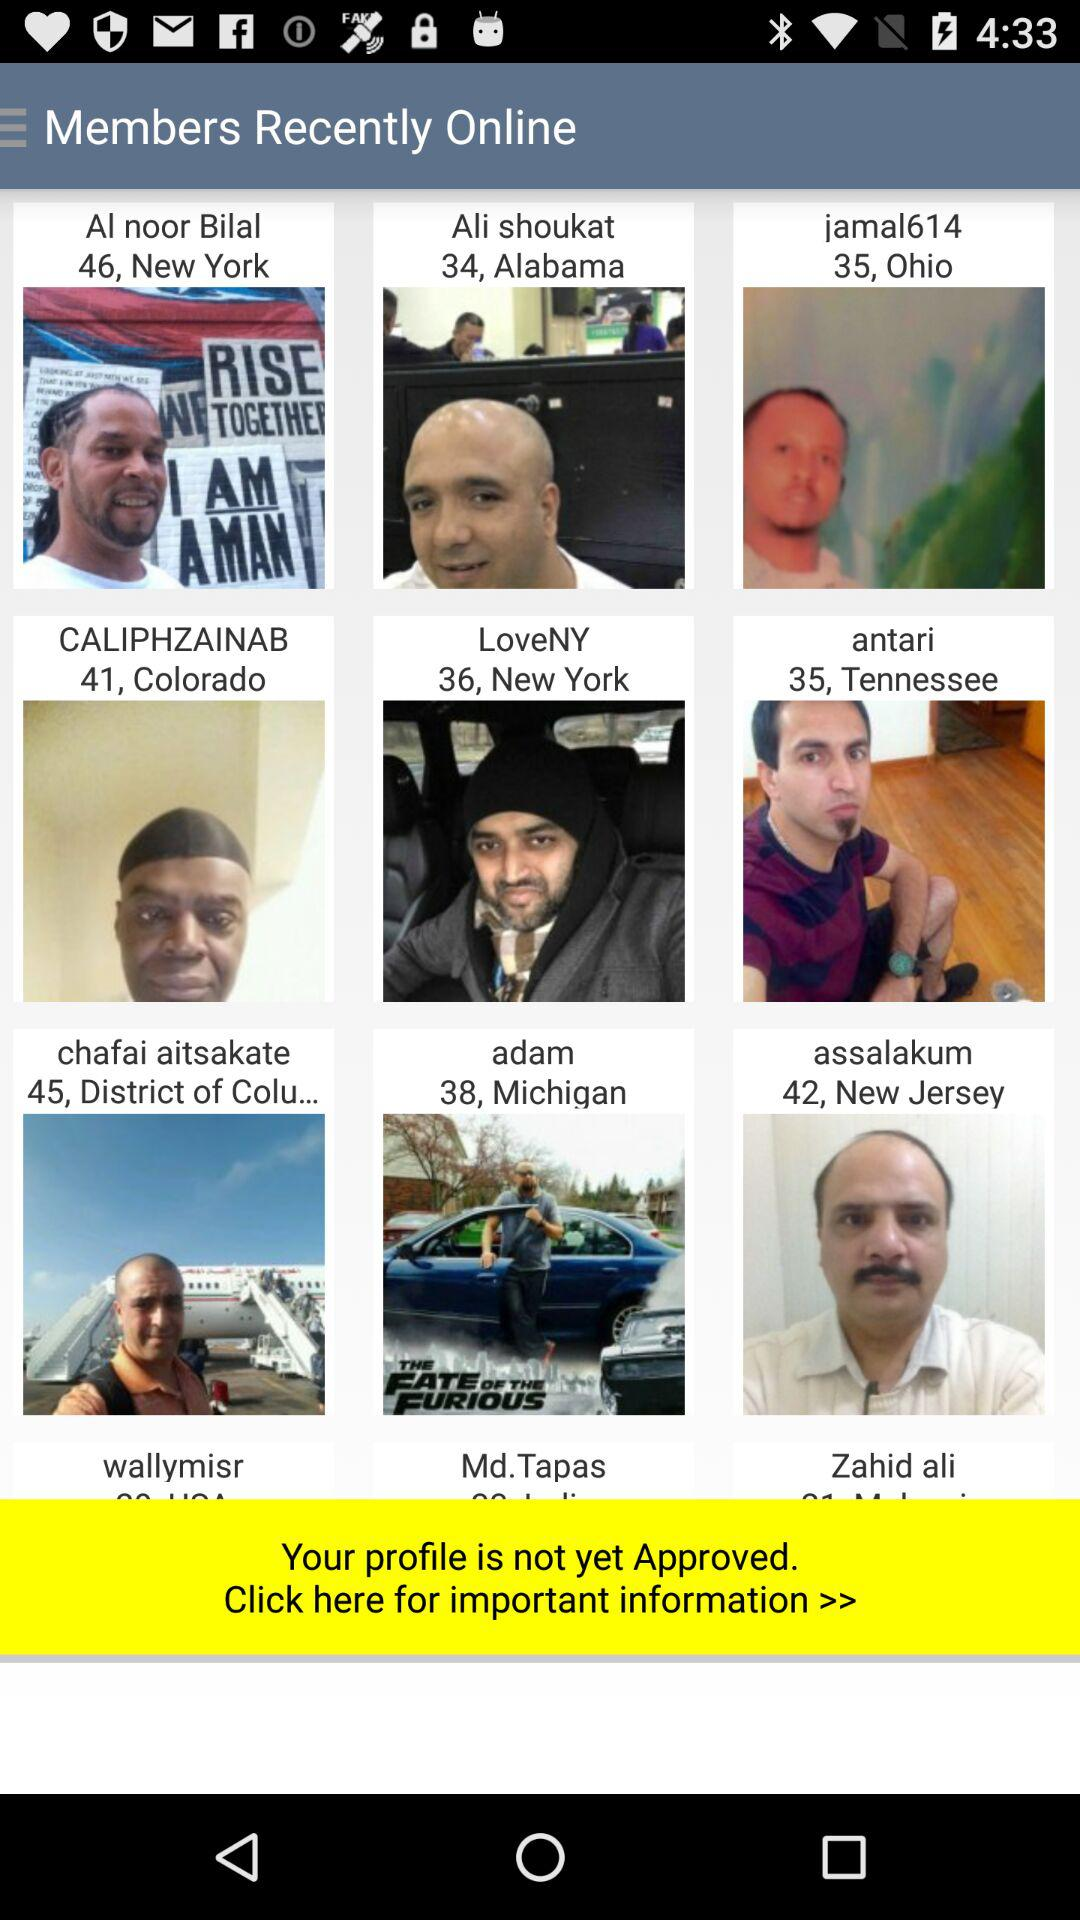Which is the location of Al Noor Bilal? The location of Al Noor Bilal is New York. 